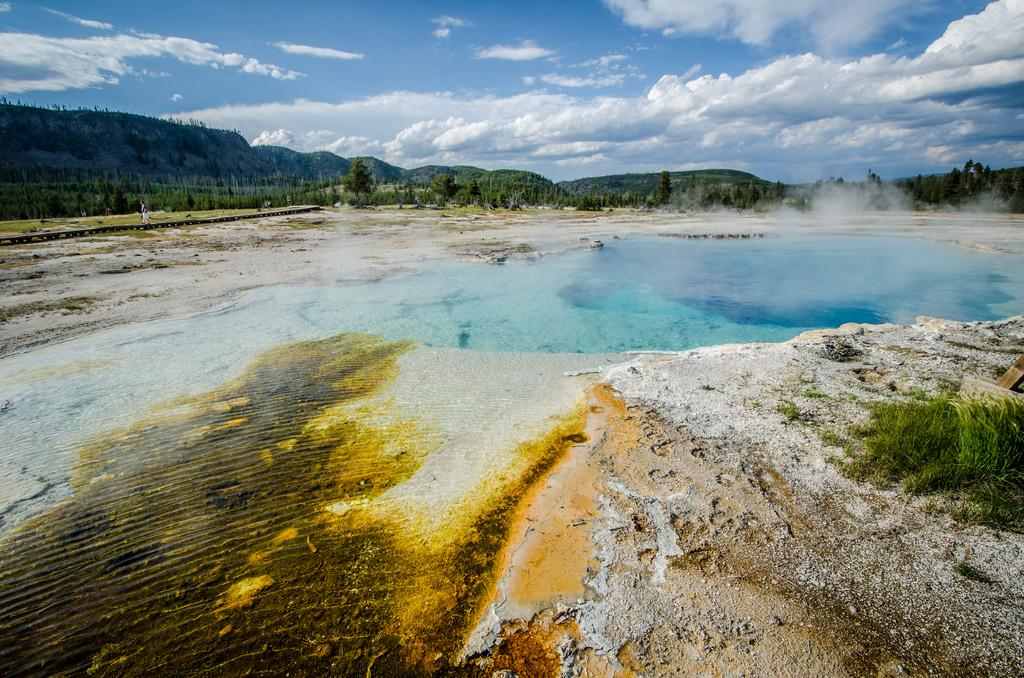What type of vegetation can be seen in the image? There is grass in the image. What else is visible besides grass? Water, trees, hills, and the sky are visible in the image. Can you describe the terrain in the image? The image features grass, water, trees, hills, and the sky, suggesting a natural landscape. What type of button can be seen on the loaf in the image? There is no loaf or button present in the image. 